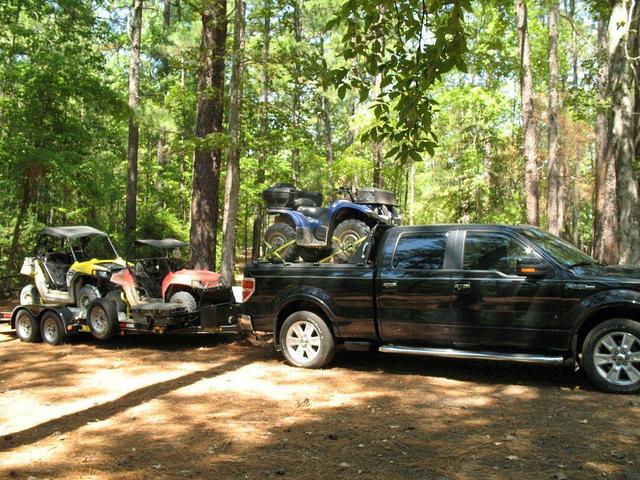Where is the truck?
Concise answer only. Woods. How many vehicles is the truck hauling?
Short answer required. 3. What color is the truck?
Be succinct. Black. 